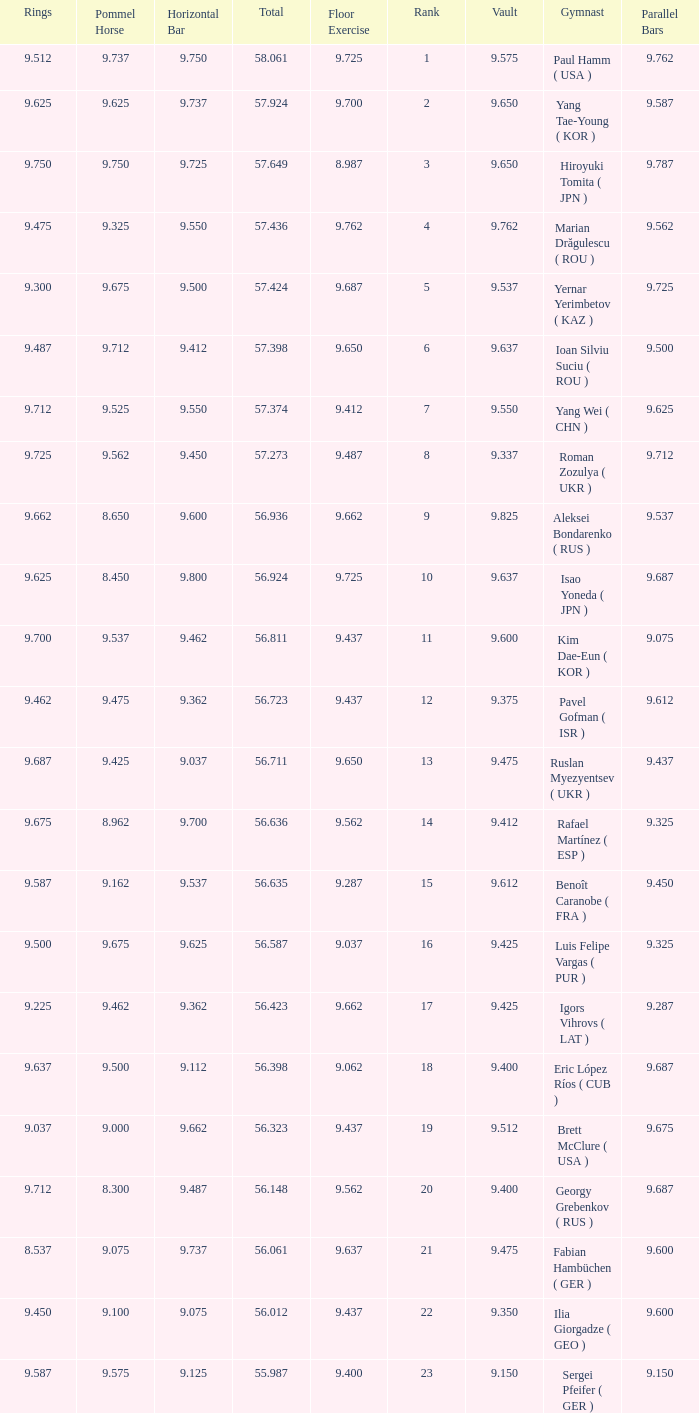Write the full table. {'header': ['Rings', 'Pommel Horse', 'Horizontal Bar', 'Total', 'Floor Exercise', 'Rank', 'Vault', 'Gymnast', 'Parallel Bars'], 'rows': [['9.512', '9.737', '9.750', '58.061', '9.725', '1', '9.575', 'Paul Hamm ( USA )', '9.762'], ['9.625', '9.625', '9.737', '57.924', '9.700', '2', '9.650', 'Yang Tae-Young ( KOR )', '9.587'], ['9.750', '9.750', '9.725', '57.649', '8.987', '3', '9.650', 'Hiroyuki Tomita ( JPN )', '9.787'], ['9.475', '9.325', '9.550', '57.436', '9.762', '4', '9.762', 'Marian Drăgulescu ( ROU )', '9.562'], ['9.300', '9.675', '9.500', '57.424', '9.687', '5', '9.537', 'Yernar Yerimbetov ( KAZ )', '9.725'], ['9.487', '9.712', '9.412', '57.398', '9.650', '6', '9.637', 'Ioan Silviu Suciu ( ROU )', '9.500'], ['9.712', '9.525', '9.550', '57.374', '9.412', '7', '9.550', 'Yang Wei ( CHN )', '9.625'], ['9.725', '9.562', '9.450', '57.273', '9.487', '8', '9.337', 'Roman Zozulya ( UKR )', '9.712'], ['9.662', '8.650', '9.600', '56.936', '9.662', '9', '9.825', 'Aleksei Bondarenko ( RUS )', '9.537'], ['9.625', '8.450', '9.800', '56.924', '9.725', '10', '9.637', 'Isao Yoneda ( JPN )', '9.687'], ['9.700', '9.537', '9.462', '56.811', '9.437', '11', '9.600', 'Kim Dae-Eun ( KOR )', '9.075'], ['9.462', '9.475', '9.362', '56.723', '9.437', '12', '9.375', 'Pavel Gofman ( ISR )', '9.612'], ['9.687', '9.425', '9.037', '56.711', '9.650', '13', '9.475', 'Ruslan Myezyentsev ( UKR )', '9.437'], ['9.675', '8.962', '9.700', '56.636', '9.562', '14', '9.412', 'Rafael Martínez ( ESP )', '9.325'], ['9.587', '9.162', '9.537', '56.635', '9.287', '15', '9.612', 'Benoît Caranobe ( FRA )', '9.450'], ['9.500', '9.675', '9.625', '56.587', '9.037', '16', '9.425', 'Luis Felipe Vargas ( PUR )', '9.325'], ['9.225', '9.462', '9.362', '56.423', '9.662', '17', '9.425', 'Igors Vihrovs ( LAT )', '9.287'], ['9.637', '9.500', '9.112', '56.398', '9.062', '18', '9.400', 'Eric López Ríos ( CUB )', '9.687'], ['9.037', '9.000', '9.662', '56.323', '9.437', '19', '9.512', 'Brett McClure ( USA )', '9.675'], ['9.712', '8.300', '9.487', '56.148', '9.562', '20', '9.400', 'Georgy Grebenkov ( RUS )', '9.687'], ['8.537', '9.075', '9.737', '56.061', '9.637', '21', '9.475', 'Fabian Hambüchen ( GER )', '9.600'], ['9.450', '9.100', '9.075', '56.012', '9.437', '22', '9.350', 'Ilia Giorgadze ( GEO )', '9.600'], ['9.587', '9.575', '9.125', '55.987', '9.400', '23', '9.150', 'Sergei Pfeifer ( GER )', '9.150']]} What is the vault score for the total of 56.635? 9.612. 